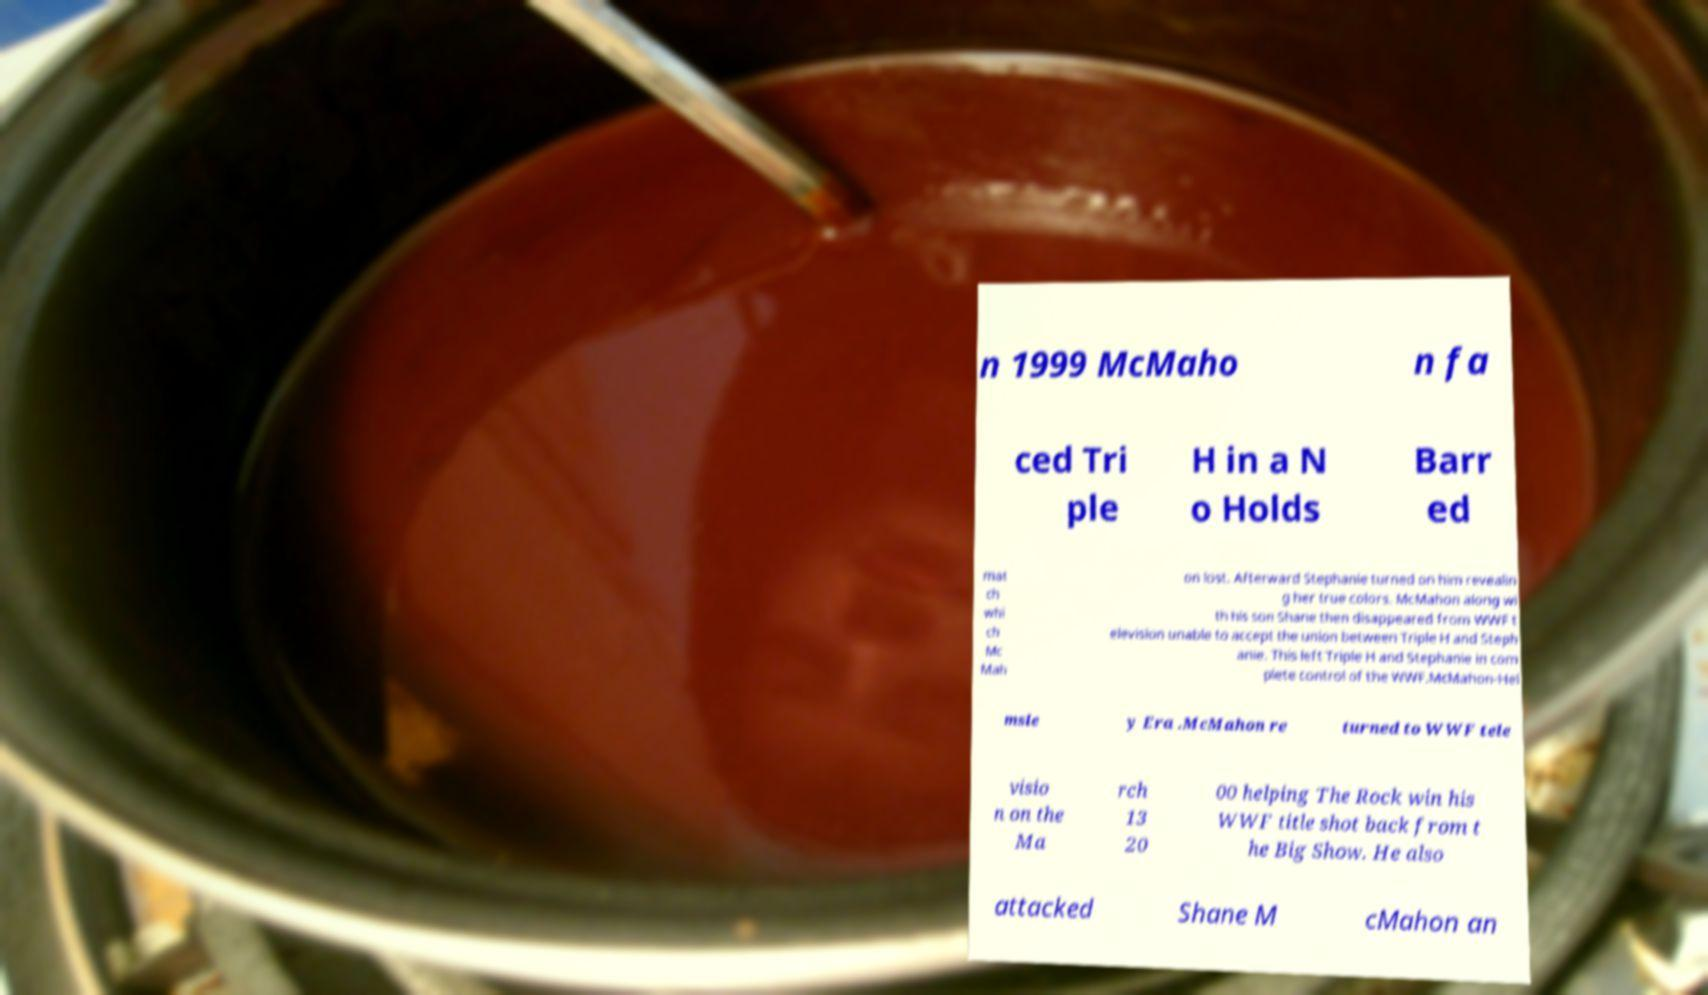Could you extract and type out the text from this image? n 1999 McMaho n fa ced Tri ple H in a N o Holds Barr ed mat ch whi ch Mc Mah on lost. Afterward Stephanie turned on him revealin g her true colors. McMahon along wi th his son Shane then disappeared from WWF t elevision unable to accept the union between Triple H and Steph anie. This left Triple H and Stephanie in com plete control of the WWF.McMahon-Hel msle y Era .McMahon re turned to WWF tele visio n on the Ma rch 13 20 00 helping The Rock win his WWF title shot back from t he Big Show. He also attacked Shane M cMahon an 